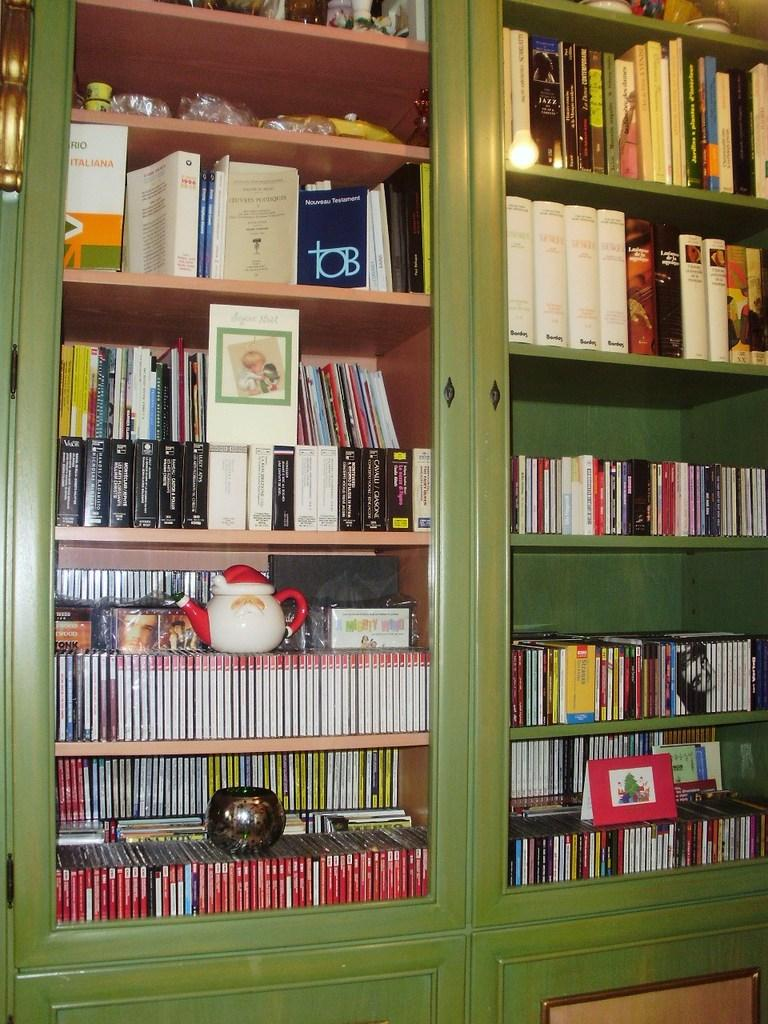<image>
Write a terse but informative summary of the picture. A bookshelf featuring a collection of books including jazz titles, Italiana among others. 